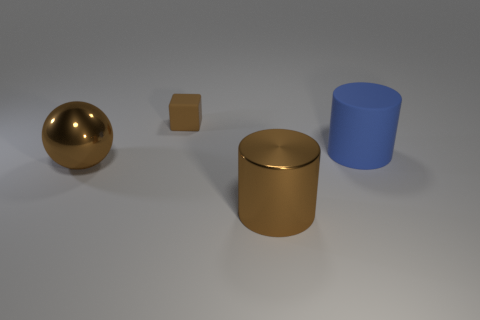What shape is the big blue thing that is the same material as the small block?
Offer a terse response. Cylinder. There is a large brown metal object that is in front of the large metallic sphere; is its shape the same as the tiny brown rubber object?
Give a very brief answer. No. There is a cylinder that is behind the brown shiny object behind the brown cylinder; how big is it?
Provide a succinct answer. Large. What is the color of the thing that is made of the same material as the small brown cube?
Provide a succinct answer. Blue. How many blue matte cylinders have the same size as the brown cylinder?
Your answer should be compact. 1. How many brown objects are either shiny things or small metallic things?
Your response must be concise. 2. How many objects are big spheres or metallic objects to the left of the tiny cube?
Your answer should be very brief. 1. What is the large object that is on the left side of the small rubber block made of?
Make the answer very short. Metal. There is a blue thing that is the same size as the metal cylinder; what shape is it?
Offer a very short reply. Cylinder. Is there another small brown rubber object that has the same shape as the brown matte thing?
Your answer should be very brief. No. 